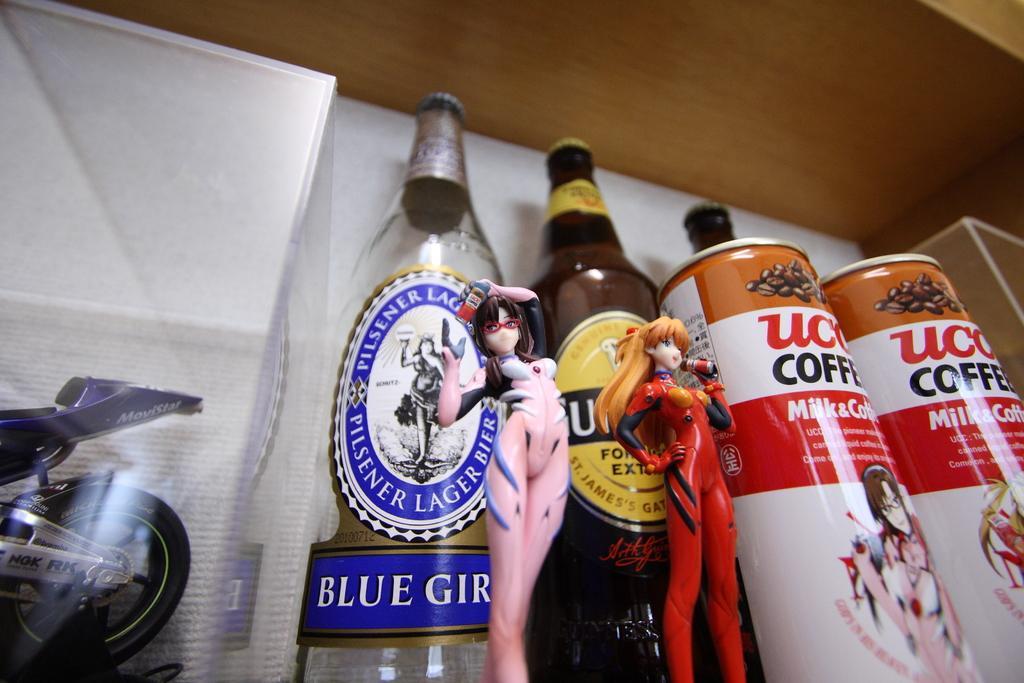Can you describe this image briefly? On the left there is a bike toy. On the right there are tins. In the middle there are two bottles. There are two toys placed before the bottles. 